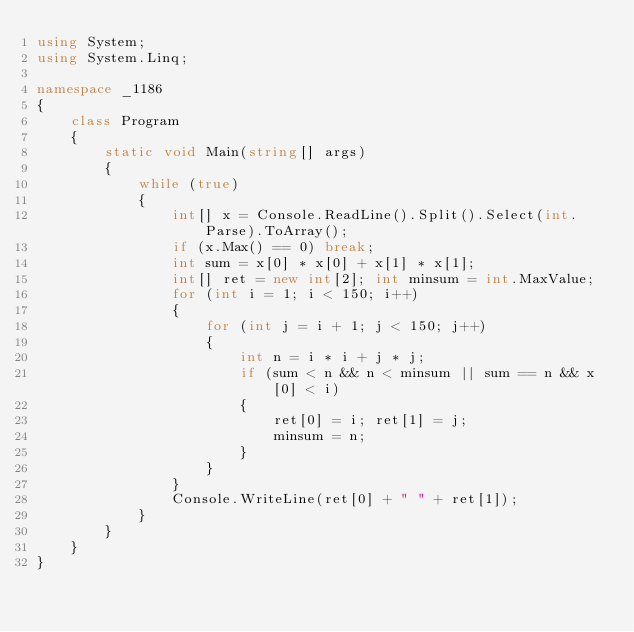Convert code to text. <code><loc_0><loc_0><loc_500><loc_500><_C#_>using System;
using System.Linq;

namespace _1186
{
    class Program
    {
        static void Main(string[] args)
        {
            while (true)
            {
                int[] x = Console.ReadLine().Split().Select(int.Parse).ToArray();
                if (x.Max() == 0) break;
                int sum = x[0] * x[0] + x[1] * x[1];
                int[] ret = new int[2]; int minsum = int.MaxValue;
                for (int i = 1; i < 150; i++)
                {
                    for (int j = i + 1; j < 150; j++)
                    {
                        int n = i * i + j * j;
                        if (sum < n && n < minsum || sum == n && x[0] < i)
                        {
                            ret[0] = i; ret[1] = j;
                            minsum = n;
                        }
                    }
                }
                Console.WriteLine(ret[0] + " " + ret[1]);
            }
        }
    }
}
</code> 